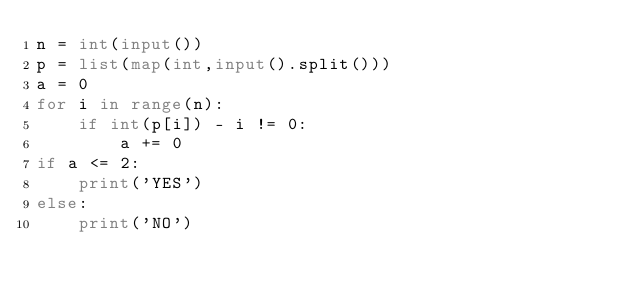Convert code to text. <code><loc_0><loc_0><loc_500><loc_500><_Python_>n = int(input())
p = list(map(int,input().split()))
a = 0
for i in range(n):
    if int(p[i]) - i != 0:
        a += 0
if a <= 2:
    print('YES')
else:
    print('NO')</code> 